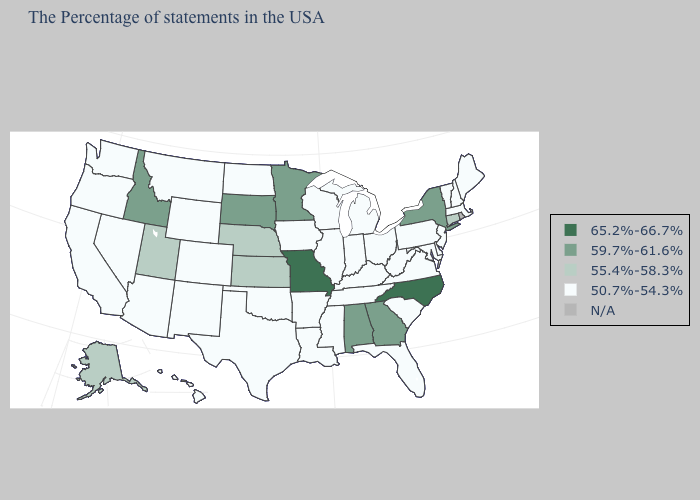What is the value of Alaska?
Write a very short answer. 55.4%-58.3%. What is the value of Minnesota?
Answer briefly. 59.7%-61.6%. What is the value of California?
Answer briefly. 50.7%-54.3%. What is the lowest value in the USA?
Answer briefly. 50.7%-54.3%. Name the states that have a value in the range 55.4%-58.3%?
Give a very brief answer. Connecticut, Kansas, Nebraska, Utah, Alaska. Name the states that have a value in the range 65.2%-66.7%?
Be succinct. North Carolina, Missouri. What is the lowest value in the MidWest?
Be succinct. 50.7%-54.3%. What is the lowest value in the West?
Concise answer only. 50.7%-54.3%. What is the value of Wyoming?
Quick response, please. 50.7%-54.3%. Name the states that have a value in the range N/A?
Concise answer only. Rhode Island. Name the states that have a value in the range 55.4%-58.3%?
Concise answer only. Connecticut, Kansas, Nebraska, Utah, Alaska. How many symbols are there in the legend?
Concise answer only. 5. Does the map have missing data?
Short answer required. Yes. 